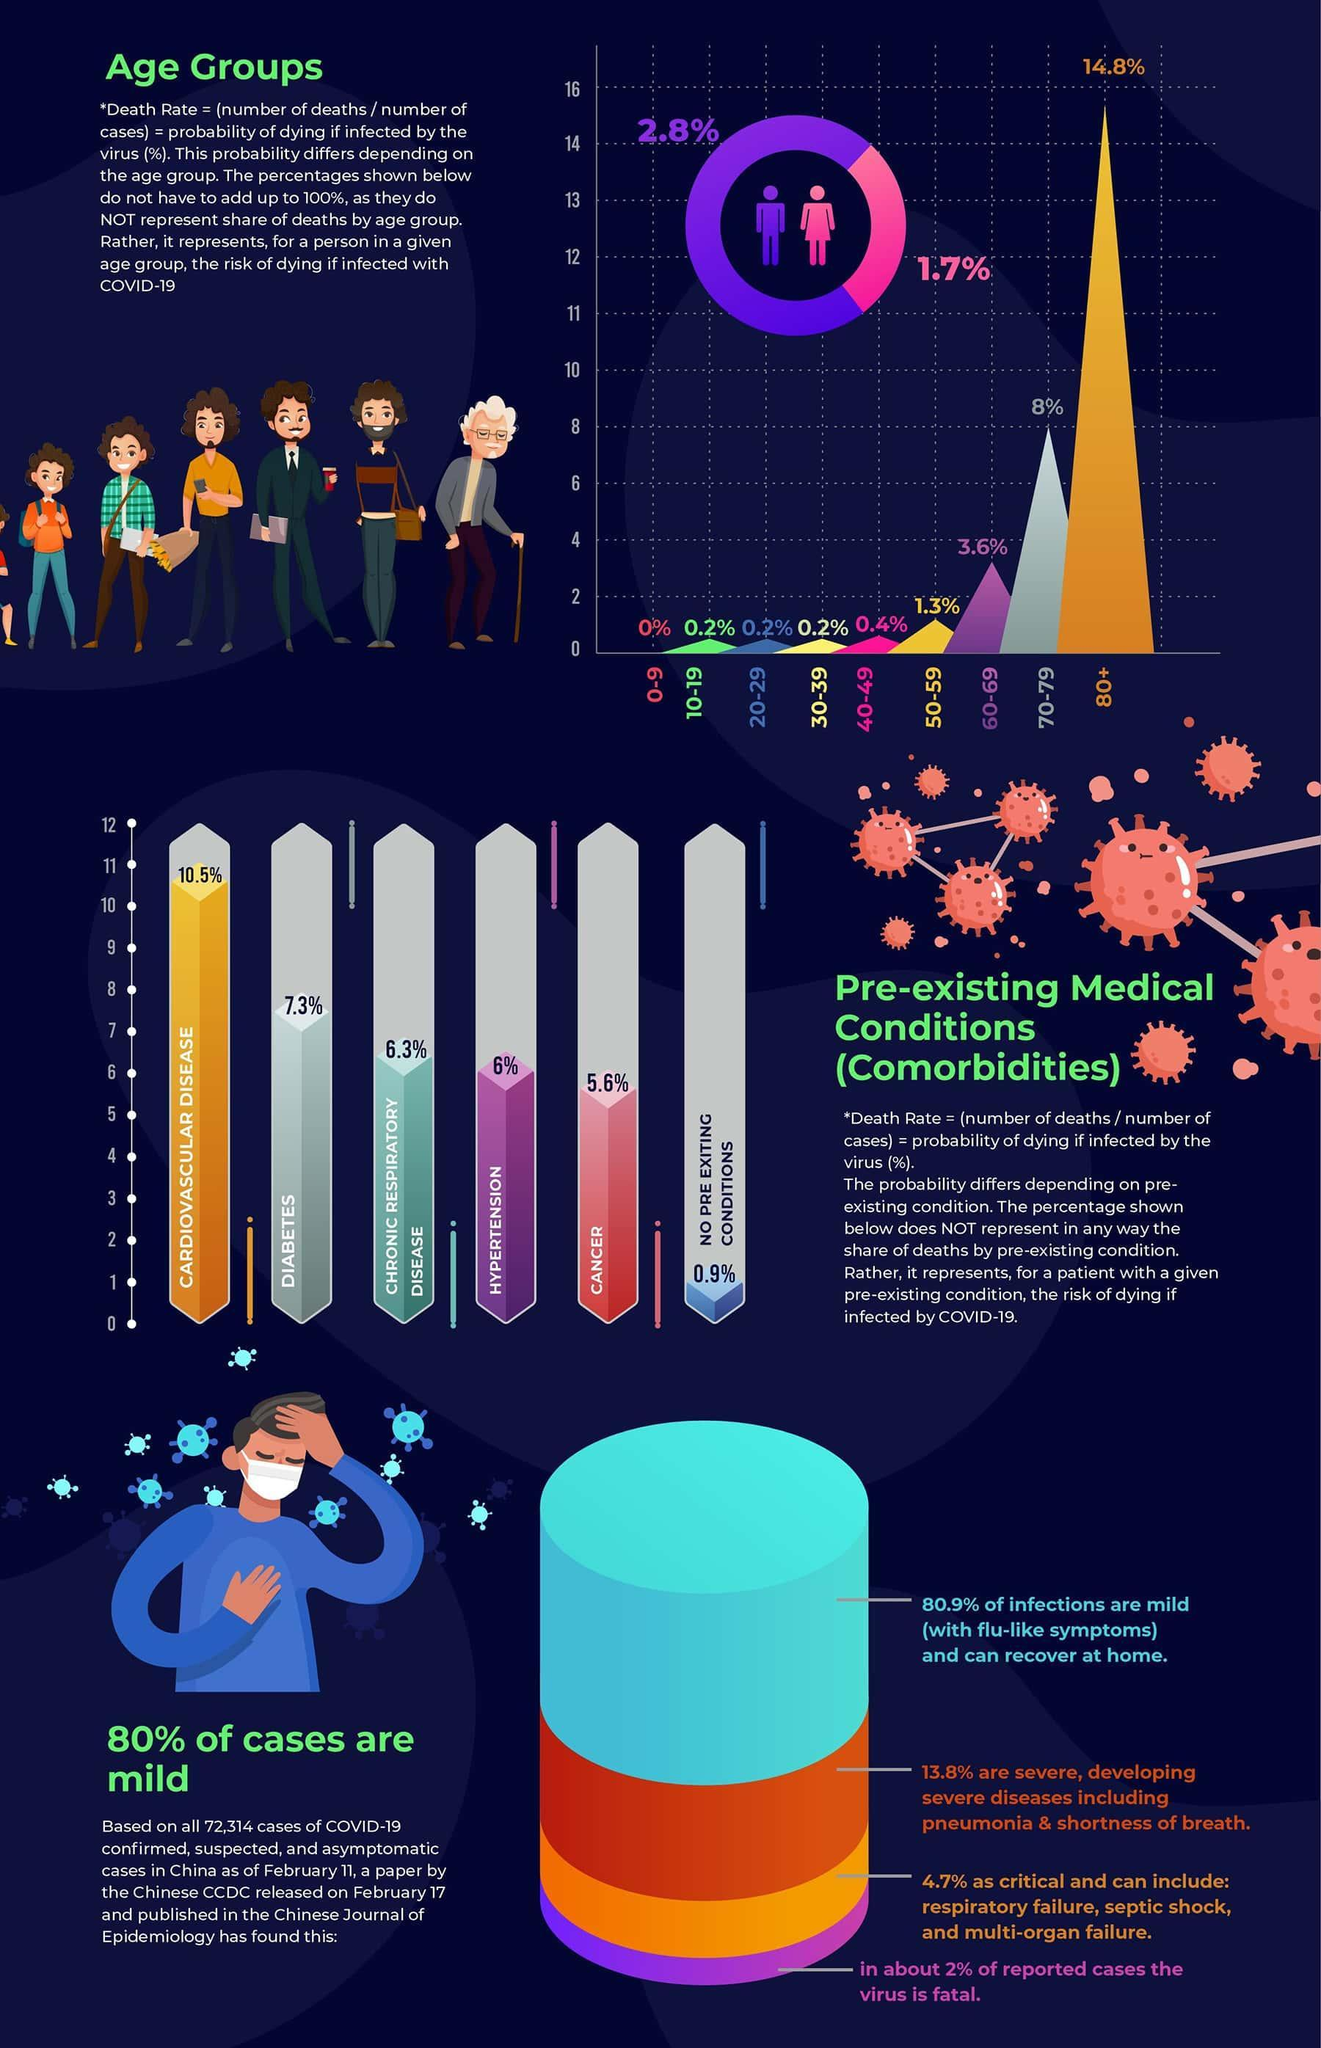What percentage of people in the age group of 20-29 have the risk of dying from covid?
Answer the question with a short phrase. 0.2% What percent of males have probability of death due to infection? 2.8% What percent of deaths are due to cardiovascular disease? 10.5% Which pre existing condition causes death in 6.3% of the cases? CHRONIC RESPIRATORY DISEASE What percent of senior citizens above the age of 60 have higher probablity of death? 26.4% What percent of deaths are caused by hypertension and cancer? 11.6% 